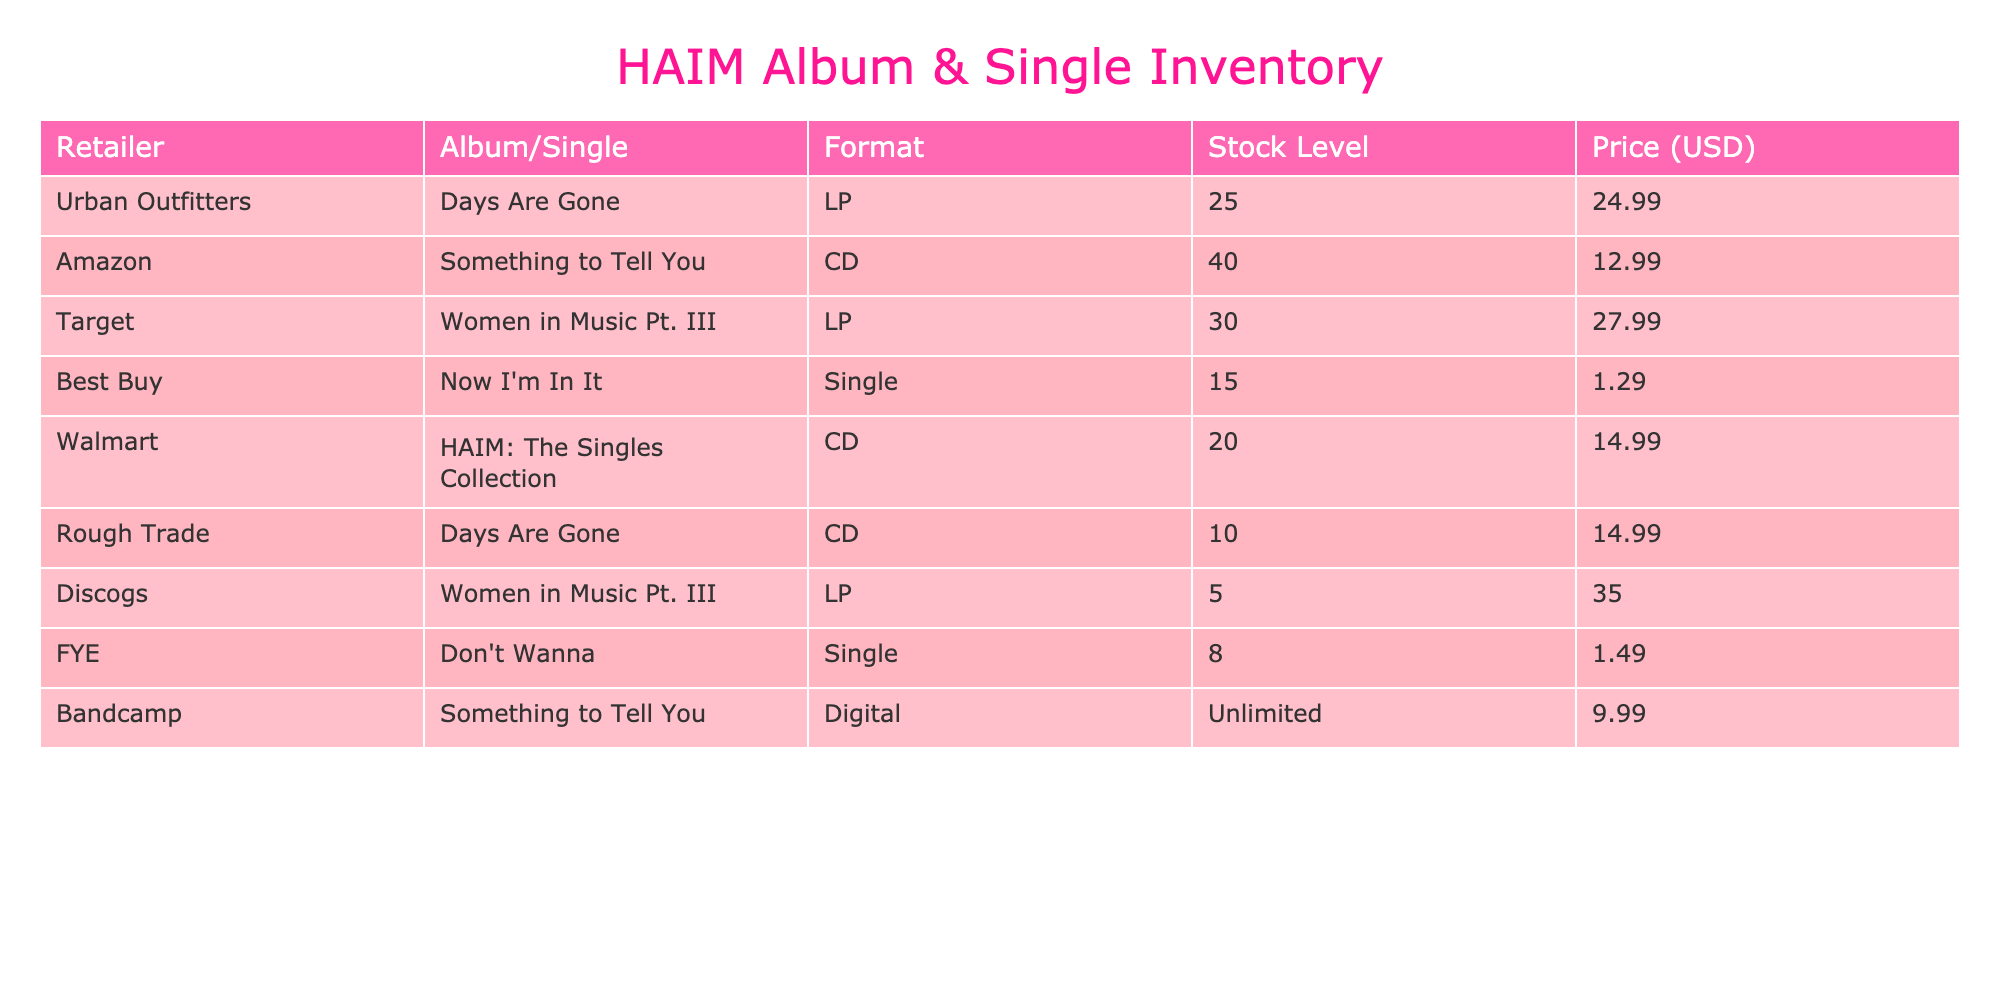What is the stock level of "Women in Music Pt. III" at Target? The table lists "Women in Music Pt. III" under Target with a stock level of 30.
Answer: 30 Which retailer has the highest stock level of Haim's albums or singles? Looking at the stock levels, Urban Outfitters has the highest stock level for an album, with 25 copies of "Days Are Gone."
Answer: Urban Outfitters Is "Don't Wanna" available in any format other than Single? The table shows that "Don't Wanna" is only listed as a Single with no other formats available.
Answer: No What is the total stock level of Haim's albums in CD format? The table shows two entries for CDs: "Something to Tell You" at 40 and "HAIM: The Singles Collection" at 20. Adding these gives 40 + 20 = 60.
Answer: 60 How much does it cost to buy both LP versions of Haim's albums? The LPs listed are "Days Are Gone" at 24.99 and "Women in Music Pt. III" at 27.99. Adding these gives 24.99 + 27.99 = 52.98.
Answer: 52.98 Is there any retailer with limited stock of Haim's albums? The table indicates that Discogs has a limited stock of only 5 for "Women in Music Pt. III."
Answer: Yes What is the price difference between the singles "Don't Wanna" and "Now I'm In It"? The price of "Don't Wanna" is 1.49 and "Now I'm In It" is 1.29. The difference is 1.49 - 1.29 = 0.20.
Answer: 0.20 How many total albums are available across all the retailers listed? The table shows 3 albums: "Days Are Gone," "Something to Tell You," and "Women in Music Pt. III." Thus, there are 3 albums in total.
Answer: 3 Which single has the lowest price available? The single "Now I'm In It" is priced at 1.29, which is lower than "Don't Wanna" at 1.49.
Answer: Now I'm In It 